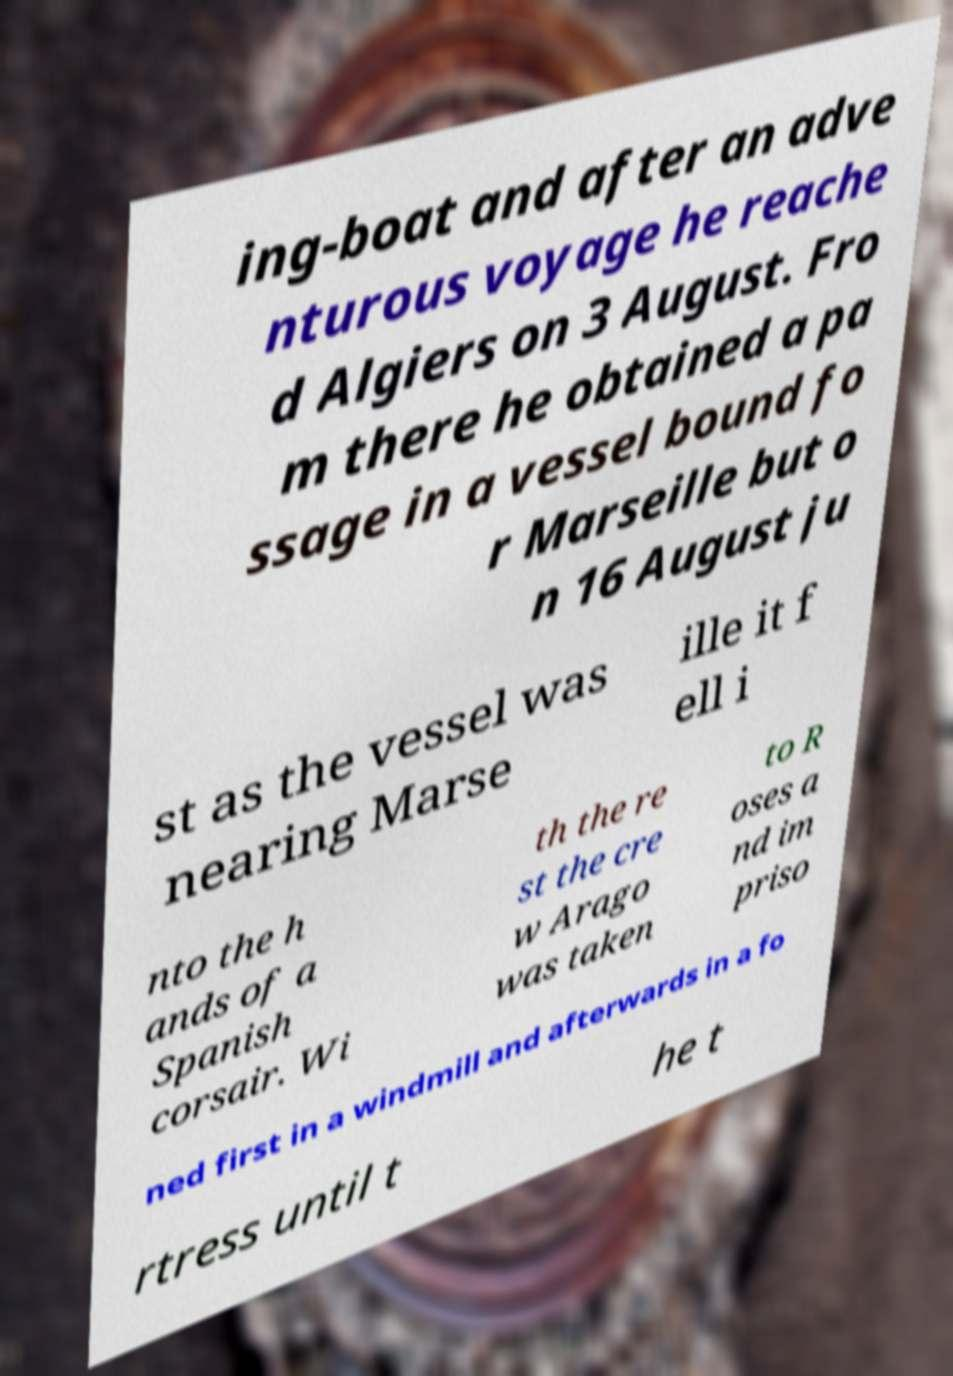Could you assist in decoding the text presented in this image and type it out clearly? ing-boat and after an adve nturous voyage he reache d Algiers on 3 August. Fro m there he obtained a pa ssage in a vessel bound fo r Marseille but o n 16 August ju st as the vessel was nearing Marse ille it f ell i nto the h ands of a Spanish corsair. Wi th the re st the cre w Arago was taken to R oses a nd im priso ned first in a windmill and afterwards in a fo rtress until t he t 